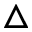<formula> <loc_0><loc_0><loc_500><loc_500>\triangle</formula> 